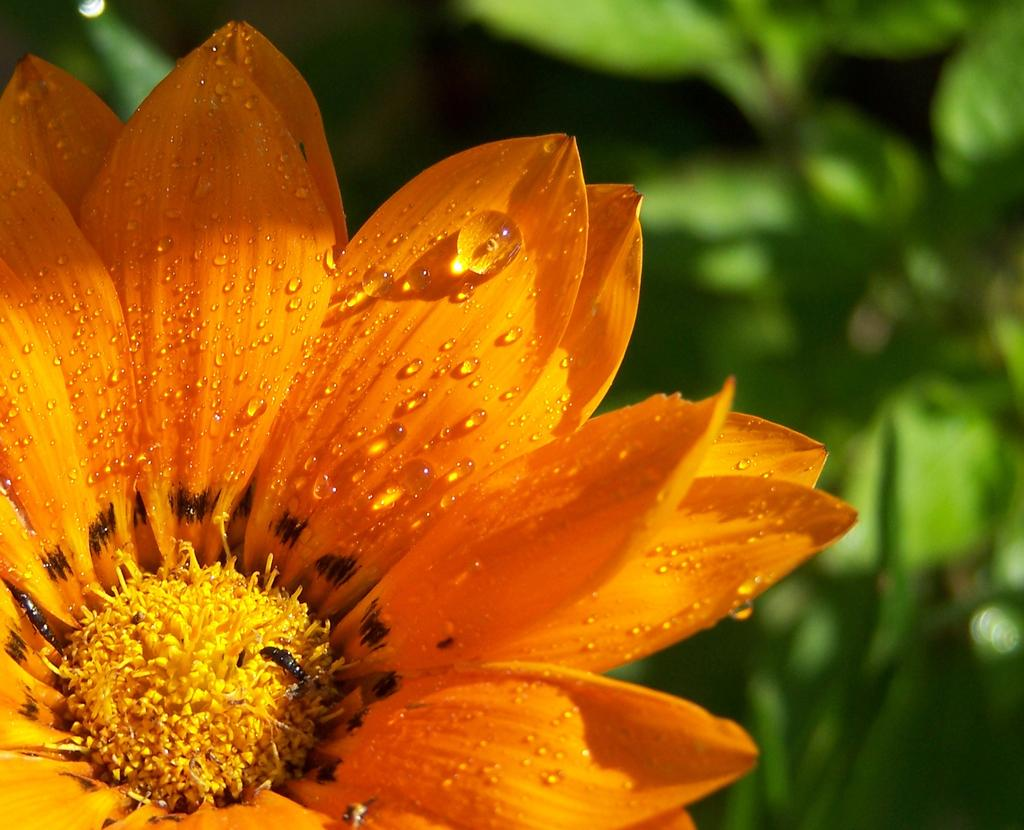What is the main subject of the image? There is a flower in the image. What can be seen in the background of the image? There are leaves in the background of the image. How would you describe the quality of the image? The image is blurry. What type of teeth can be seen in the image? There are no teeth present in the image; it features a flower and leaves. What kind of quartz is visible in the image? There is no quartz present in the image. 